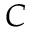<formula> <loc_0><loc_0><loc_500><loc_500>C</formula> 